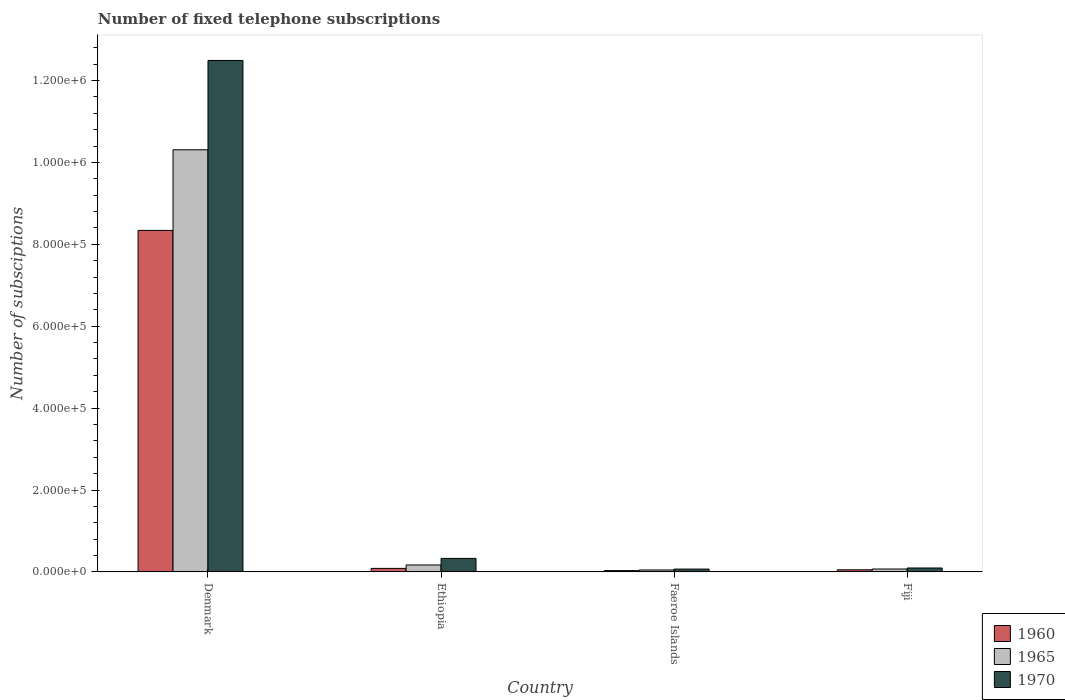How many different coloured bars are there?
Provide a short and direct response. 3. How many groups of bars are there?
Offer a terse response. 4. Are the number of bars per tick equal to the number of legend labels?
Offer a very short reply. Yes. How many bars are there on the 1st tick from the left?
Your answer should be compact. 3. What is the label of the 3rd group of bars from the left?
Offer a very short reply. Faeroe Islands. In how many cases, is the number of bars for a given country not equal to the number of legend labels?
Offer a terse response. 0. What is the number of fixed telephone subscriptions in 1970 in Fiji?
Your answer should be compact. 9600. Across all countries, what is the maximum number of fixed telephone subscriptions in 1965?
Provide a succinct answer. 1.03e+06. Across all countries, what is the minimum number of fixed telephone subscriptions in 1960?
Provide a short and direct response. 3208. In which country was the number of fixed telephone subscriptions in 1960 minimum?
Provide a succinct answer. Faeroe Islands. What is the total number of fixed telephone subscriptions in 1965 in the graph?
Provide a short and direct response. 1.06e+06. What is the difference between the number of fixed telephone subscriptions in 1965 in Faeroe Islands and that in Fiji?
Your answer should be very brief. -2335. What is the difference between the number of fixed telephone subscriptions in 1960 in Fiji and the number of fixed telephone subscriptions in 1965 in Denmark?
Make the answer very short. -1.03e+06. What is the average number of fixed telephone subscriptions in 1965 per country?
Offer a terse response. 2.65e+05. What is the difference between the number of fixed telephone subscriptions of/in 1965 and number of fixed telephone subscriptions of/in 1960 in Fiji?
Provide a succinct answer. 1936. What is the ratio of the number of fixed telephone subscriptions in 1960 in Ethiopia to that in Faeroe Islands?
Ensure brevity in your answer.  2.69. What is the difference between the highest and the second highest number of fixed telephone subscriptions in 1960?
Make the answer very short. 8.25e+05. What is the difference between the highest and the lowest number of fixed telephone subscriptions in 1965?
Provide a short and direct response. 1.03e+06. Is the sum of the number of fixed telephone subscriptions in 1970 in Ethiopia and Faeroe Islands greater than the maximum number of fixed telephone subscriptions in 1965 across all countries?
Provide a succinct answer. No. What does the 1st bar from the left in Denmark represents?
Your response must be concise. 1960. Is it the case that in every country, the sum of the number of fixed telephone subscriptions in 1970 and number of fixed telephone subscriptions in 1960 is greater than the number of fixed telephone subscriptions in 1965?
Ensure brevity in your answer.  Yes. What is the difference between two consecutive major ticks on the Y-axis?
Your answer should be very brief. 2.00e+05. What is the title of the graph?
Provide a succinct answer. Number of fixed telephone subscriptions. Does "2013" appear as one of the legend labels in the graph?
Give a very brief answer. No. What is the label or title of the X-axis?
Your answer should be very brief. Country. What is the label or title of the Y-axis?
Your answer should be compact. Number of subsciptions. What is the Number of subsciptions in 1960 in Denmark?
Provide a succinct answer. 8.34e+05. What is the Number of subsciptions of 1965 in Denmark?
Your response must be concise. 1.03e+06. What is the Number of subsciptions of 1970 in Denmark?
Provide a short and direct response. 1.25e+06. What is the Number of subsciptions in 1960 in Ethiopia?
Your answer should be compact. 8636. What is the Number of subsciptions of 1965 in Ethiopia?
Your answer should be very brief. 1.70e+04. What is the Number of subsciptions in 1970 in Ethiopia?
Ensure brevity in your answer.  3.30e+04. What is the Number of subsciptions of 1960 in Faeroe Islands?
Make the answer very short. 3208. What is the Number of subsciptions of 1965 in Faeroe Islands?
Your answer should be compact. 4765. What is the Number of subsciptions of 1970 in Faeroe Islands?
Give a very brief answer. 6910. What is the Number of subsciptions of 1960 in Fiji?
Give a very brief answer. 5164. What is the Number of subsciptions of 1965 in Fiji?
Offer a very short reply. 7100. What is the Number of subsciptions in 1970 in Fiji?
Your answer should be compact. 9600. Across all countries, what is the maximum Number of subsciptions of 1960?
Give a very brief answer. 8.34e+05. Across all countries, what is the maximum Number of subsciptions of 1965?
Keep it short and to the point. 1.03e+06. Across all countries, what is the maximum Number of subsciptions of 1970?
Provide a succinct answer. 1.25e+06. Across all countries, what is the minimum Number of subsciptions in 1960?
Your response must be concise. 3208. Across all countries, what is the minimum Number of subsciptions of 1965?
Ensure brevity in your answer.  4765. Across all countries, what is the minimum Number of subsciptions in 1970?
Your answer should be very brief. 6910. What is the total Number of subsciptions of 1960 in the graph?
Your answer should be compact. 8.51e+05. What is the total Number of subsciptions in 1965 in the graph?
Ensure brevity in your answer.  1.06e+06. What is the total Number of subsciptions in 1970 in the graph?
Keep it short and to the point. 1.30e+06. What is the difference between the Number of subsciptions in 1960 in Denmark and that in Ethiopia?
Make the answer very short. 8.25e+05. What is the difference between the Number of subsciptions in 1965 in Denmark and that in Ethiopia?
Offer a terse response. 1.01e+06. What is the difference between the Number of subsciptions of 1970 in Denmark and that in Ethiopia?
Your response must be concise. 1.22e+06. What is the difference between the Number of subsciptions of 1960 in Denmark and that in Faeroe Islands?
Your response must be concise. 8.31e+05. What is the difference between the Number of subsciptions of 1965 in Denmark and that in Faeroe Islands?
Your answer should be compact. 1.03e+06. What is the difference between the Number of subsciptions of 1970 in Denmark and that in Faeroe Islands?
Your answer should be very brief. 1.24e+06. What is the difference between the Number of subsciptions in 1960 in Denmark and that in Fiji?
Your response must be concise. 8.29e+05. What is the difference between the Number of subsciptions of 1965 in Denmark and that in Fiji?
Ensure brevity in your answer.  1.02e+06. What is the difference between the Number of subsciptions in 1970 in Denmark and that in Fiji?
Provide a succinct answer. 1.24e+06. What is the difference between the Number of subsciptions in 1960 in Ethiopia and that in Faeroe Islands?
Offer a very short reply. 5428. What is the difference between the Number of subsciptions in 1965 in Ethiopia and that in Faeroe Islands?
Keep it short and to the point. 1.22e+04. What is the difference between the Number of subsciptions in 1970 in Ethiopia and that in Faeroe Islands?
Offer a terse response. 2.61e+04. What is the difference between the Number of subsciptions in 1960 in Ethiopia and that in Fiji?
Provide a short and direct response. 3472. What is the difference between the Number of subsciptions in 1965 in Ethiopia and that in Fiji?
Your answer should be compact. 9900. What is the difference between the Number of subsciptions of 1970 in Ethiopia and that in Fiji?
Give a very brief answer. 2.34e+04. What is the difference between the Number of subsciptions of 1960 in Faeroe Islands and that in Fiji?
Give a very brief answer. -1956. What is the difference between the Number of subsciptions of 1965 in Faeroe Islands and that in Fiji?
Make the answer very short. -2335. What is the difference between the Number of subsciptions in 1970 in Faeroe Islands and that in Fiji?
Provide a short and direct response. -2690. What is the difference between the Number of subsciptions of 1960 in Denmark and the Number of subsciptions of 1965 in Ethiopia?
Provide a short and direct response. 8.17e+05. What is the difference between the Number of subsciptions in 1960 in Denmark and the Number of subsciptions in 1970 in Ethiopia?
Offer a very short reply. 8.01e+05. What is the difference between the Number of subsciptions in 1965 in Denmark and the Number of subsciptions in 1970 in Ethiopia?
Your response must be concise. 9.98e+05. What is the difference between the Number of subsciptions of 1960 in Denmark and the Number of subsciptions of 1965 in Faeroe Islands?
Your answer should be very brief. 8.29e+05. What is the difference between the Number of subsciptions in 1960 in Denmark and the Number of subsciptions in 1970 in Faeroe Islands?
Offer a very short reply. 8.27e+05. What is the difference between the Number of subsciptions in 1965 in Denmark and the Number of subsciptions in 1970 in Faeroe Islands?
Keep it short and to the point. 1.02e+06. What is the difference between the Number of subsciptions of 1960 in Denmark and the Number of subsciptions of 1965 in Fiji?
Keep it short and to the point. 8.27e+05. What is the difference between the Number of subsciptions in 1960 in Denmark and the Number of subsciptions in 1970 in Fiji?
Your answer should be very brief. 8.24e+05. What is the difference between the Number of subsciptions in 1965 in Denmark and the Number of subsciptions in 1970 in Fiji?
Ensure brevity in your answer.  1.02e+06. What is the difference between the Number of subsciptions of 1960 in Ethiopia and the Number of subsciptions of 1965 in Faeroe Islands?
Your response must be concise. 3871. What is the difference between the Number of subsciptions of 1960 in Ethiopia and the Number of subsciptions of 1970 in Faeroe Islands?
Your answer should be compact. 1726. What is the difference between the Number of subsciptions of 1965 in Ethiopia and the Number of subsciptions of 1970 in Faeroe Islands?
Offer a very short reply. 1.01e+04. What is the difference between the Number of subsciptions of 1960 in Ethiopia and the Number of subsciptions of 1965 in Fiji?
Your answer should be very brief. 1536. What is the difference between the Number of subsciptions of 1960 in Ethiopia and the Number of subsciptions of 1970 in Fiji?
Your response must be concise. -964. What is the difference between the Number of subsciptions in 1965 in Ethiopia and the Number of subsciptions in 1970 in Fiji?
Ensure brevity in your answer.  7400. What is the difference between the Number of subsciptions of 1960 in Faeroe Islands and the Number of subsciptions of 1965 in Fiji?
Offer a very short reply. -3892. What is the difference between the Number of subsciptions of 1960 in Faeroe Islands and the Number of subsciptions of 1970 in Fiji?
Provide a succinct answer. -6392. What is the difference between the Number of subsciptions in 1965 in Faeroe Islands and the Number of subsciptions in 1970 in Fiji?
Give a very brief answer. -4835. What is the average Number of subsciptions in 1960 per country?
Provide a succinct answer. 2.13e+05. What is the average Number of subsciptions of 1965 per country?
Give a very brief answer. 2.65e+05. What is the average Number of subsciptions in 1970 per country?
Offer a terse response. 3.25e+05. What is the difference between the Number of subsciptions of 1960 and Number of subsciptions of 1965 in Denmark?
Your response must be concise. -1.97e+05. What is the difference between the Number of subsciptions in 1960 and Number of subsciptions in 1970 in Denmark?
Your answer should be compact. -4.15e+05. What is the difference between the Number of subsciptions in 1965 and Number of subsciptions in 1970 in Denmark?
Your answer should be very brief. -2.18e+05. What is the difference between the Number of subsciptions in 1960 and Number of subsciptions in 1965 in Ethiopia?
Your answer should be compact. -8364. What is the difference between the Number of subsciptions of 1960 and Number of subsciptions of 1970 in Ethiopia?
Ensure brevity in your answer.  -2.44e+04. What is the difference between the Number of subsciptions of 1965 and Number of subsciptions of 1970 in Ethiopia?
Provide a short and direct response. -1.60e+04. What is the difference between the Number of subsciptions in 1960 and Number of subsciptions in 1965 in Faeroe Islands?
Your response must be concise. -1557. What is the difference between the Number of subsciptions of 1960 and Number of subsciptions of 1970 in Faeroe Islands?
Your answer should be very brief. -3702. What is the difference between the Number of subsciptions in 1965 and Number of subsciptions in 1970 in Faeroe Islands?
Make the answer very short. -2145. What is the difference between the Number of subsciptions of 1960 and Number of subsciptions of 1965 in Fiji?
Your answer should be compact. -1936. What is the difference between the Number of subsciptions of 1960 and Number of subsciptions of 1970 in Fiji?
Your answer should be very brief. -4436. What is the difference between the Number of subsciptions in 1965 and Number of subsciptions in 1970 in Fiji?
Make the answer very short. -2500. What is the ratio of the Number of subsciptions in 1960 in Denmark to that in Ethiopia?
Provide a succinct answer. 96.57. What is the ratio of the Number of subsciptions of 1965 in Denmark to that in Ethiopia?
Offer a terse response. 60.64. What is the ratio of the Number of subsciptions in 1970 in Denmark to that in Ethiopia?
Your answer should be compact. 37.85. What is the ratio of the Number of subsciptions of 1960 in Denmark to that in Faeroe Islands?
Keep it short and to the point. 259.97. What is the ratio of the Number of subsciptions of 1965 in Denmark to that in Faeroe Islands?
Keep it short and to the point. 216.34. What is the ratio of the Number of subsciptions in 1970 in Denmark to that in Faeroe Islands?
Make the answer very short. 180.75. What is the ratio of the Number of subsciptions of 1960 in Denmark to that in Fiji?
Offer a terse response. 161.5. What is the ratio of the Number of subsciptions in 1965 in Denmark to that in Fiji?
Offer a very short reply. 145.19. What is the ratio of the Number of subsciptions in 1970 in Denmark to that in Fiji?
Your answer should be compact. 130.1. What is the ratio of the Number of subsciptions of 1960 in Ethiopia to that in Faeroe Islands?
Your answer should be compact. 2.69. What is the ratio of the Number of subsciptions of 1965 in Ethiopia to that in Faeroe Islands?
Offer a terse response. 3.57. What is the ratio of the Number of subsciptions in 1970 in Ethiopia to that in Faeroe Islands?
Your answer should be compact. 4.78. What is the ratio of the Number of subsciptions in 1960 in Ethiopia to that in Fiji?
Offer a very short reply. 1.67. What is the ratio of the Number of subsciptions in 1965 in Ethiopia to that in Fiji?
Give a very brief answer. 2.39. What is the ratio of the Number of subsciptions of 1970 in Ethiopia to that in Fiji?
Your answer should be very brief. 3.44. What is the ratio of the Number of subsciptions in 1960 in Faeroe Islands to that in Fiji?
Provide a succinct answer. 0.62. What is the ratio of the Number of subsciptions in 1965 in Faeroe Islands to that in Fiji?
Offer a terse response. 0.67. What is the ratio of the Number of subsciptions in 1970 in Faeroe Islands to that in Fiji?
Give a very brief answer. 0.72. What is the difference between the highest and the second highest Number of subsciptions in 1960?
Provide a succinct answer. 8.25e+05. What is the difference between the highest and the second highest Number of subsciptions in 1965?
Your answer should be compact. 1.01e+06. What is the difference between the highest and the second highest Number of subsciptions in 1970?
Provide a succinct answer. 1.22e+06. What is the difference between the highest and the lowest Number of subsciptions in 1960?
Keep it short and to the point. 8.31e+05. What is the difference between the highest and the lowest Number of subsciptions of 1965?
Keep it short and to the point. 1.03e+06. What is the difference between the highest and the lowest Number of subsciptions in 1970?
Give a very brief answer. 1.24e+06. 